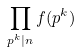Convert formula to latex. <formula><loc_0><loc_0><loc_500><loc_500>\prod _ { p ^ { k } | n } f ( p ^ { k } )</formula> 